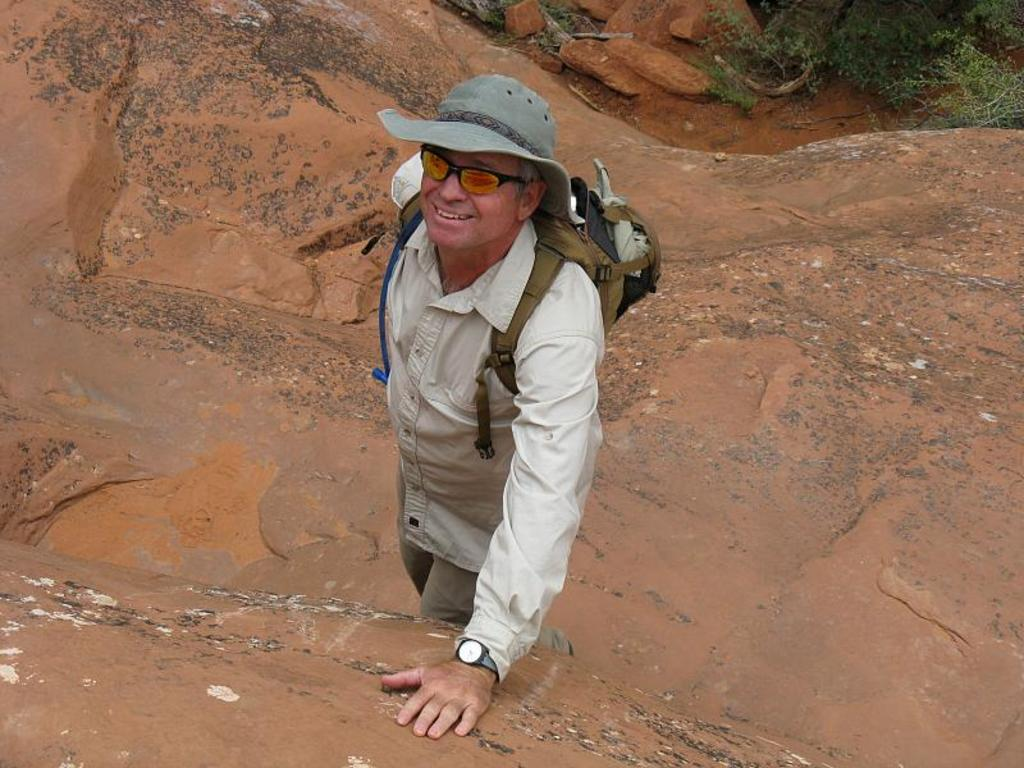What is the main subject of the image? There is a man in the image. Can you describe the man's clothing? The man is wearing a white shirt and a hat. What accessories is the man wearing? The man is wearing spectacles. What is the man carrying in the image? The man is carrying a bag. What type of natural elements can be seen in the image? There are rocks and plants in the image. What type of garden does the man tend to in the image? There is no garden present in the image. What hobbies does the man have, as indicated by the image? The image does not provide information about the man's hobbies. Can you spot an ant in the image? There is no ant present in the image. 